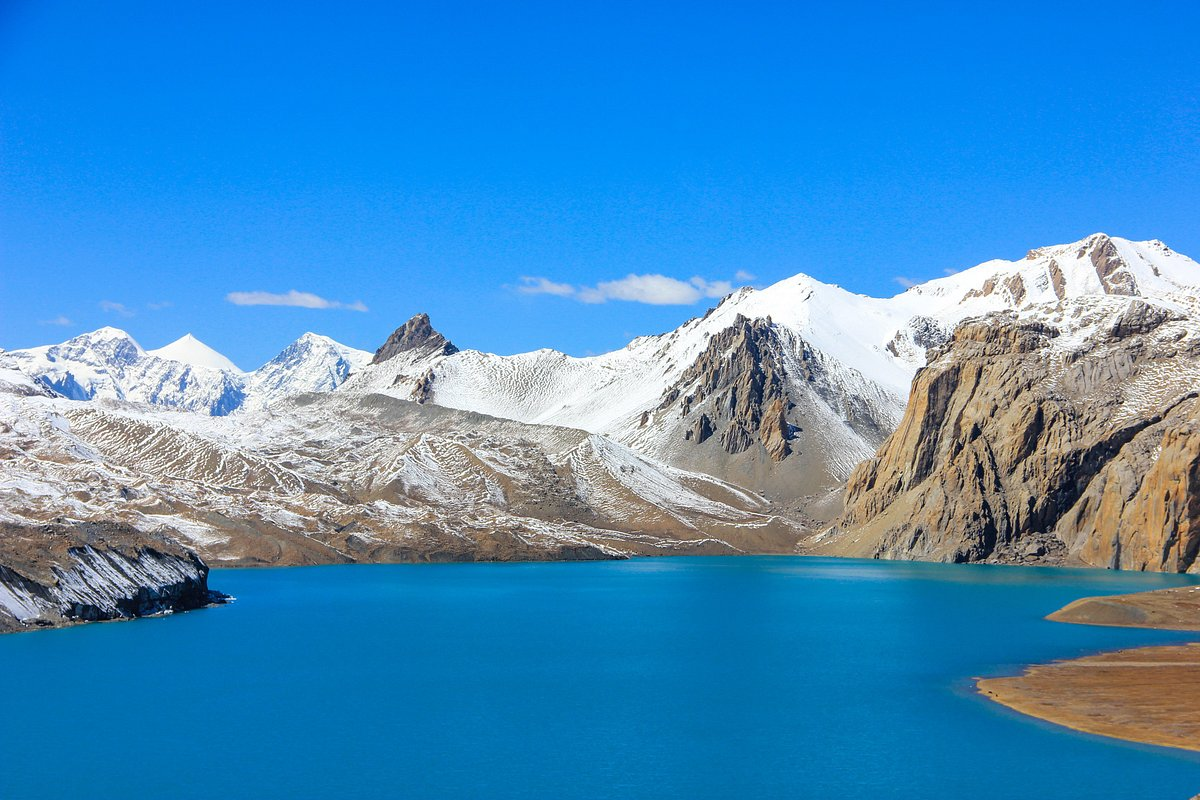What would be the best time of year to visit this place for breathtaking views? The best time to visit Tilicho Lake for breathtaking views would be in the autumn months, from September to November. During this period, the weather is generally clear and stable, providing fantastic visibility of the lake and the surrounding snow-capped peaks. The temperatures are also more moderate, making trekking conditions ideal. Alternatively, the spring months from March to May offer beautiful vistas as well, with blooming alpine flora adding vibrant colors to the landscape. 